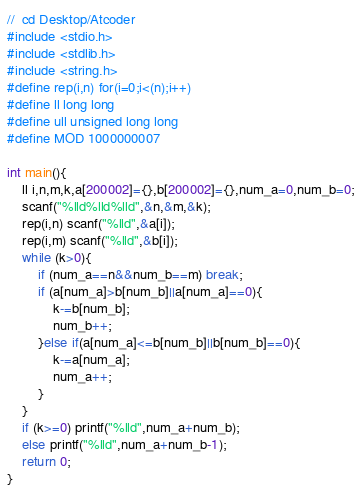Convert code to text. <code><loc_0><loc_0><loc_500><loc_500><_C_>//  cd Desktop/Atcoder
#include <stdio.h>
#include <stdlib.h>
#include <string.h>
#define rep(i,n) for(i=0;i<(n);i++)
#define ll long long
#define ull unsigned long long
#define MOD 1000000007

int main(){
    ll i,n,m,k,a[200002]={},b[200002]={},num_a=0,num_b=0;
    scanf("%lld%lld%lld",&n,&m,&k);
    rep(i,n) scanf("%lld",&a[i]);
    rep(i,m) scanf("%lld",&b[i]);
    while (k>0){
        if (num_a==n&&num_b==m) break;
        if (a[num_a]>b[num_b]||a[num_a]==0){
            k-=b[num_b];
            num_b++;
        }else if(a[num_a]<=b[num_b]||b[num_b]==0){
            k-=a[num_a];
            num_a++;
        }
    }
    if (k>=0) printf("%lld",num_a+num_b);
    else printf("%lld",num_a+num_b-1);
    return 0;
}</code> 